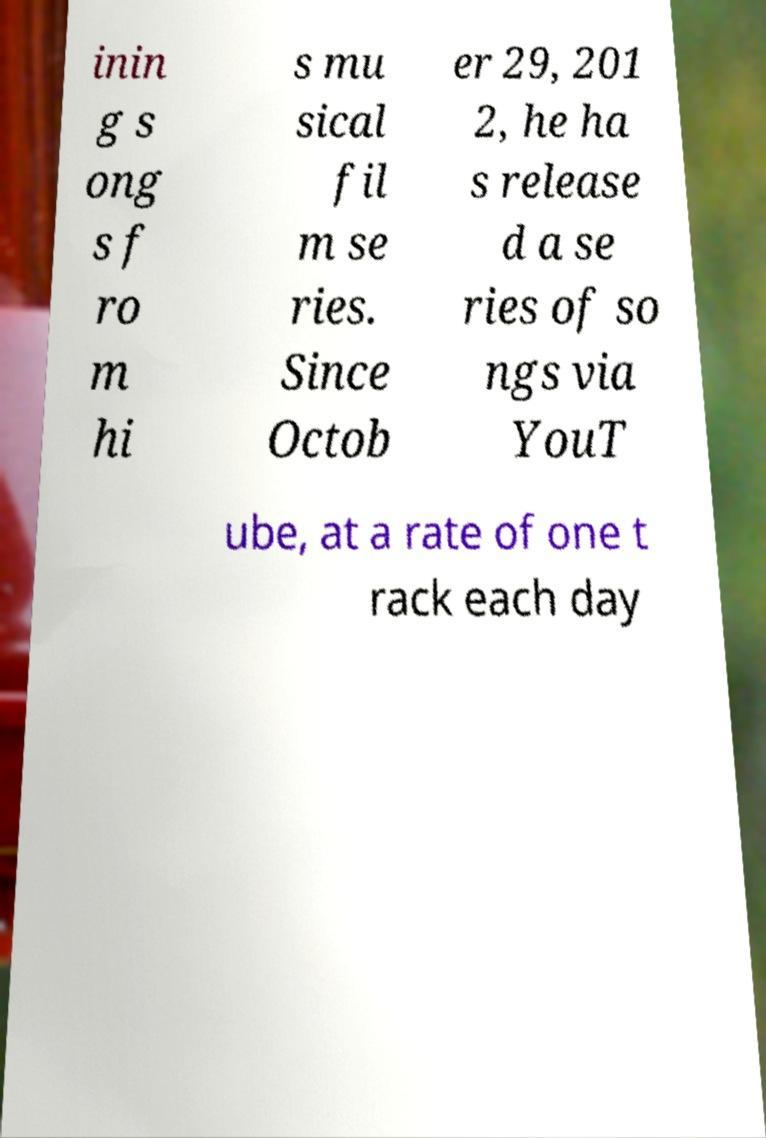There's text embedded in this image that I need extracted. Can you transcribe it verbatim? inin g s ong s f ro m hi s mu sical fil m se ries. Since Octob er 29, 201 2, he ha s release d a se ries of so ngs via YouT ube, at a rate of one t rack each day 